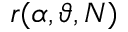Convert formula to latex. <formula><loc_0><loc_0><loc_500><loc_500>r ( \alpha , \vartheta , N )</formula> 